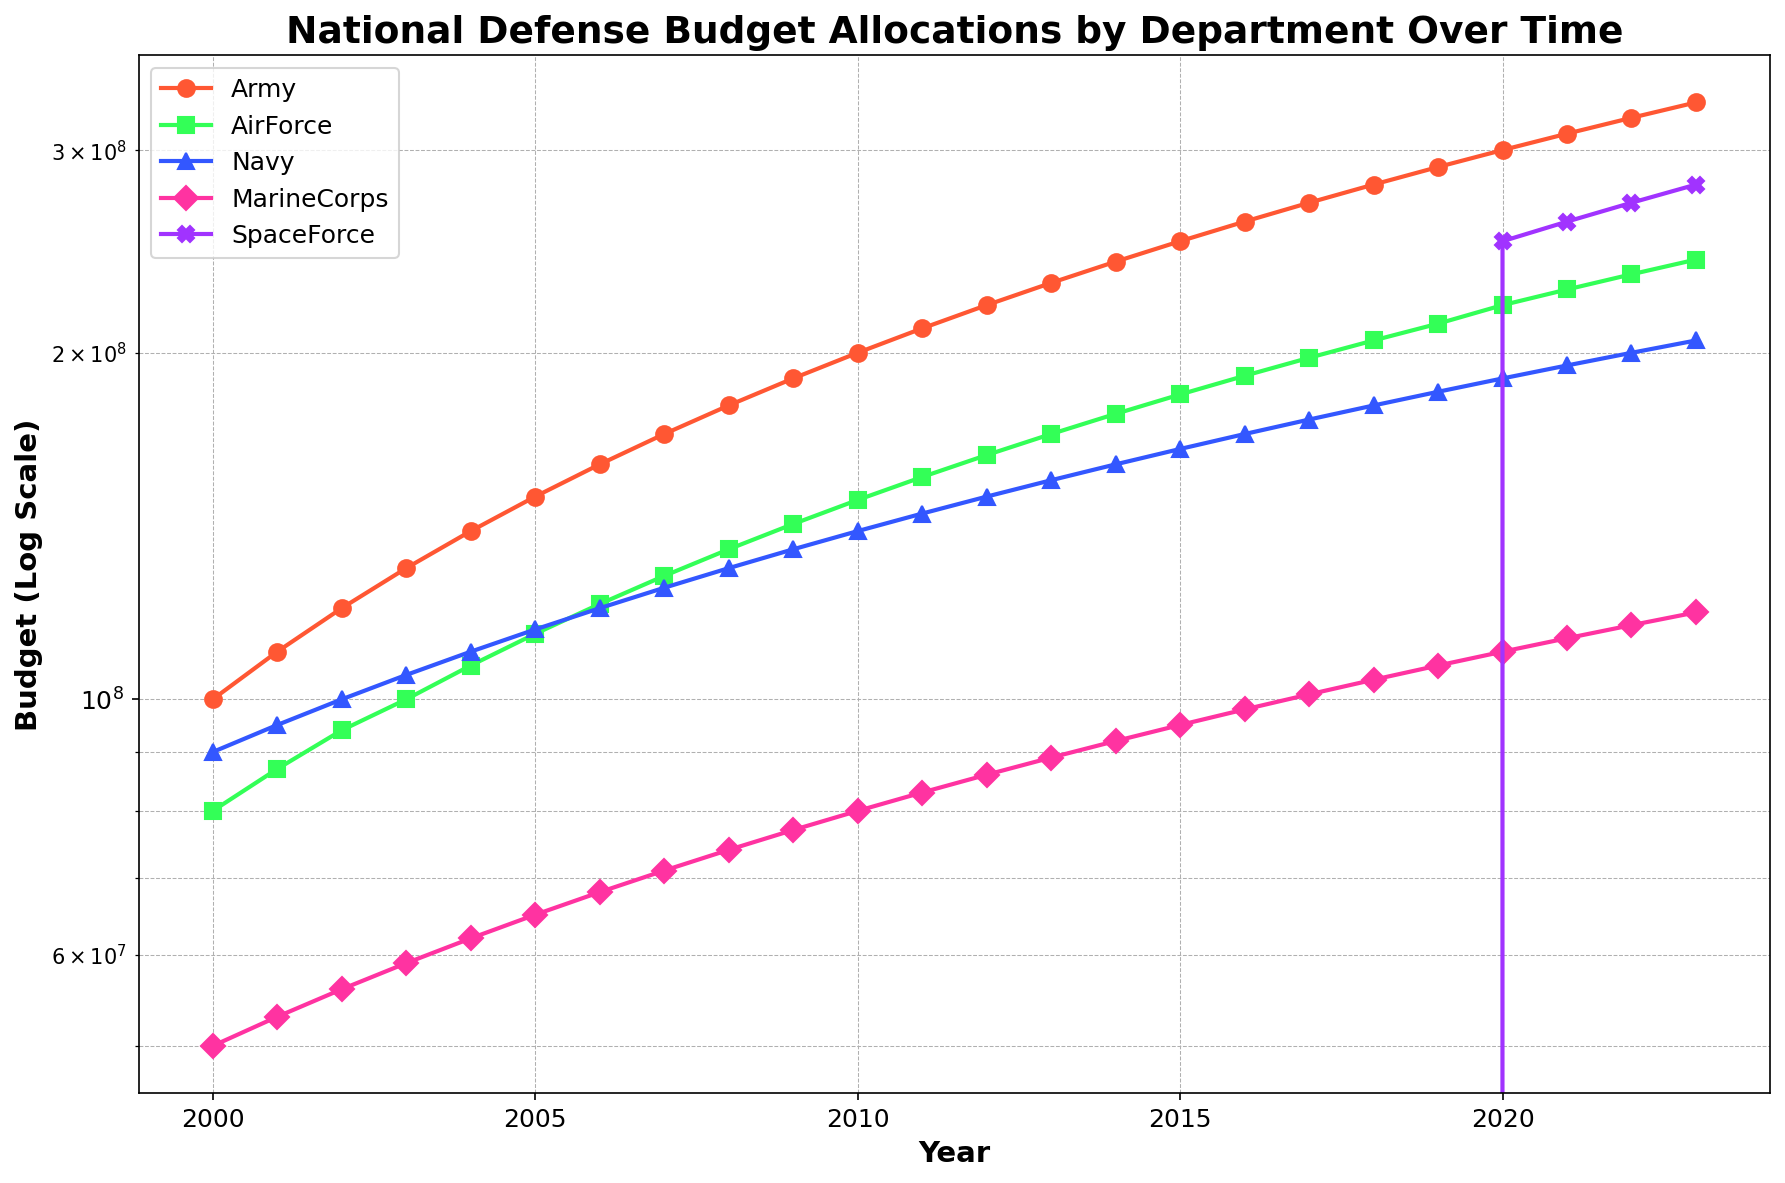What year did the Marine Corps and Navy budgets first both exceed $80,000,000? Look at the Marine Corps and Navy lines and check when both values exceed $80,000,000. This condition is first met in 2010.
Answer: 2010 Which department had the largest increase in budget from 2020 to 2023? Compare the budget values for each department between 2020 and 2023 and find the difference. The Space Force increased from $250,000,000 to $280,000,000, which is the largest increase of $30,000,000.
Answer: Space Force In what year did the Army budget reach $200,000,000? Check the Army line and find the year where it first reaches $200,000,000. This occurs in 2010.
Answer: 2010 How many years did it take for the Air Force budget to double from its 2000 value? The Air Force budget in 2000 is $80,000,000, so doubling that would be $160,000,000. Check when the Air Force budget reaches $160,000,000. This is in 2012, so it took 12 years.
Answer: 12 years Between which two years did the Space Force see the largest absolute increase in budget? Examine the Space Force line for the largest yearly increase. The increase between 2020 ($250,000,000) & 2021 ($260,000,000) is $10,000,000. Check for all the years; this remains the largest increase.
Answer: 2020 and 2021 What was the budget difference between the Army and Navy in 2022? Subtract the Navy budget from the Army budget in 2022. The values are $320,000,000 (Army) and $200,000,000 (Navy), so the difference is $120,000,000.
Answer: $120,000,000 Which department consistently had the lowest budget until 2020? Look at all departments' lines and find the one with the lowest values consistently until 2020. This is the Marine Corps.
Answer: Marine Corps 